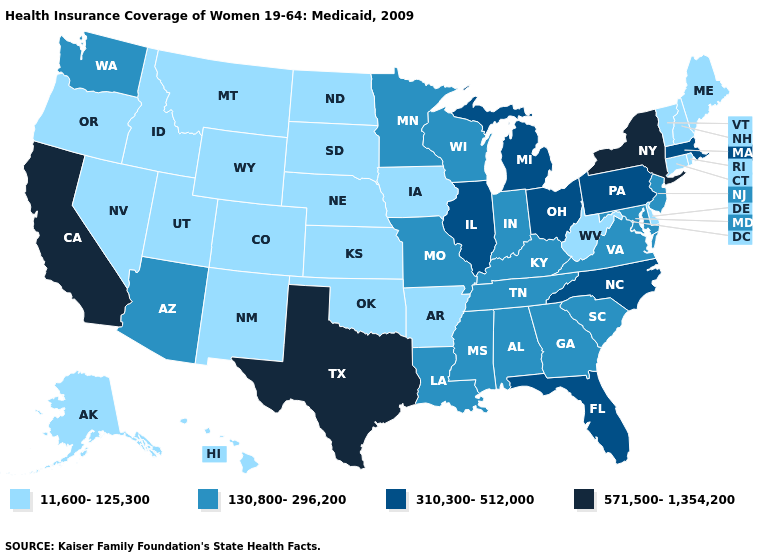What is the value of Indiana?
Write a very short answer. 130,800-296,200. What is the highest value in states that border Washington?
Answer briefly. 11,600-125,300. What is the lowest value in the MidWest?
Keep it brief. 11,600-125,300. What is the lowest value in the USA?
Answer briefly. 11,600-125,300. Name the states that have a value in the range 310,300-512,000?
Write a very short answer. Florida, Illinois, Massachusetts, Michigan, North Carolina, Ohio, Pennsylvania. Does Virginia have a higher value than Connecticut?
Give a very brief answer. Yes. Does Wisconsin have the lowest value in the USA?
Keep it brief. No. What is the highest value in the South ?
Short answer required. 571,500-1,354,200. What is the value of Rhode Island?
Give a very brief answer. 11,600-125,300. Does Connecticut have the same value as Colorado?
Be succinct. Yes. Name the states that have a value in the range 310,300-512,000?
Give a very brief answer. Florida, Illinois, Massachusetts, Michigan, North Carolina, Ohio, Pennsylvania. Which states hav the highest value in the South?
Be succinct. Texas. What is the highest value in the USA?
Be succinct. 571,500-1,354,200. Name the states that have a value in the range 130,800-296,200?
Give a very brief answer. Alabama, Arizona, Georgia, Indiana, Kentucky, Louisiana, Maryland, Minnesota, Mississippi, Missouri, New Jersey, South Carolina, Tennessee, Virginia, Washington, Wisconsin. What is the value of Delaware?
Concise answer only. 11,600-125,300. 